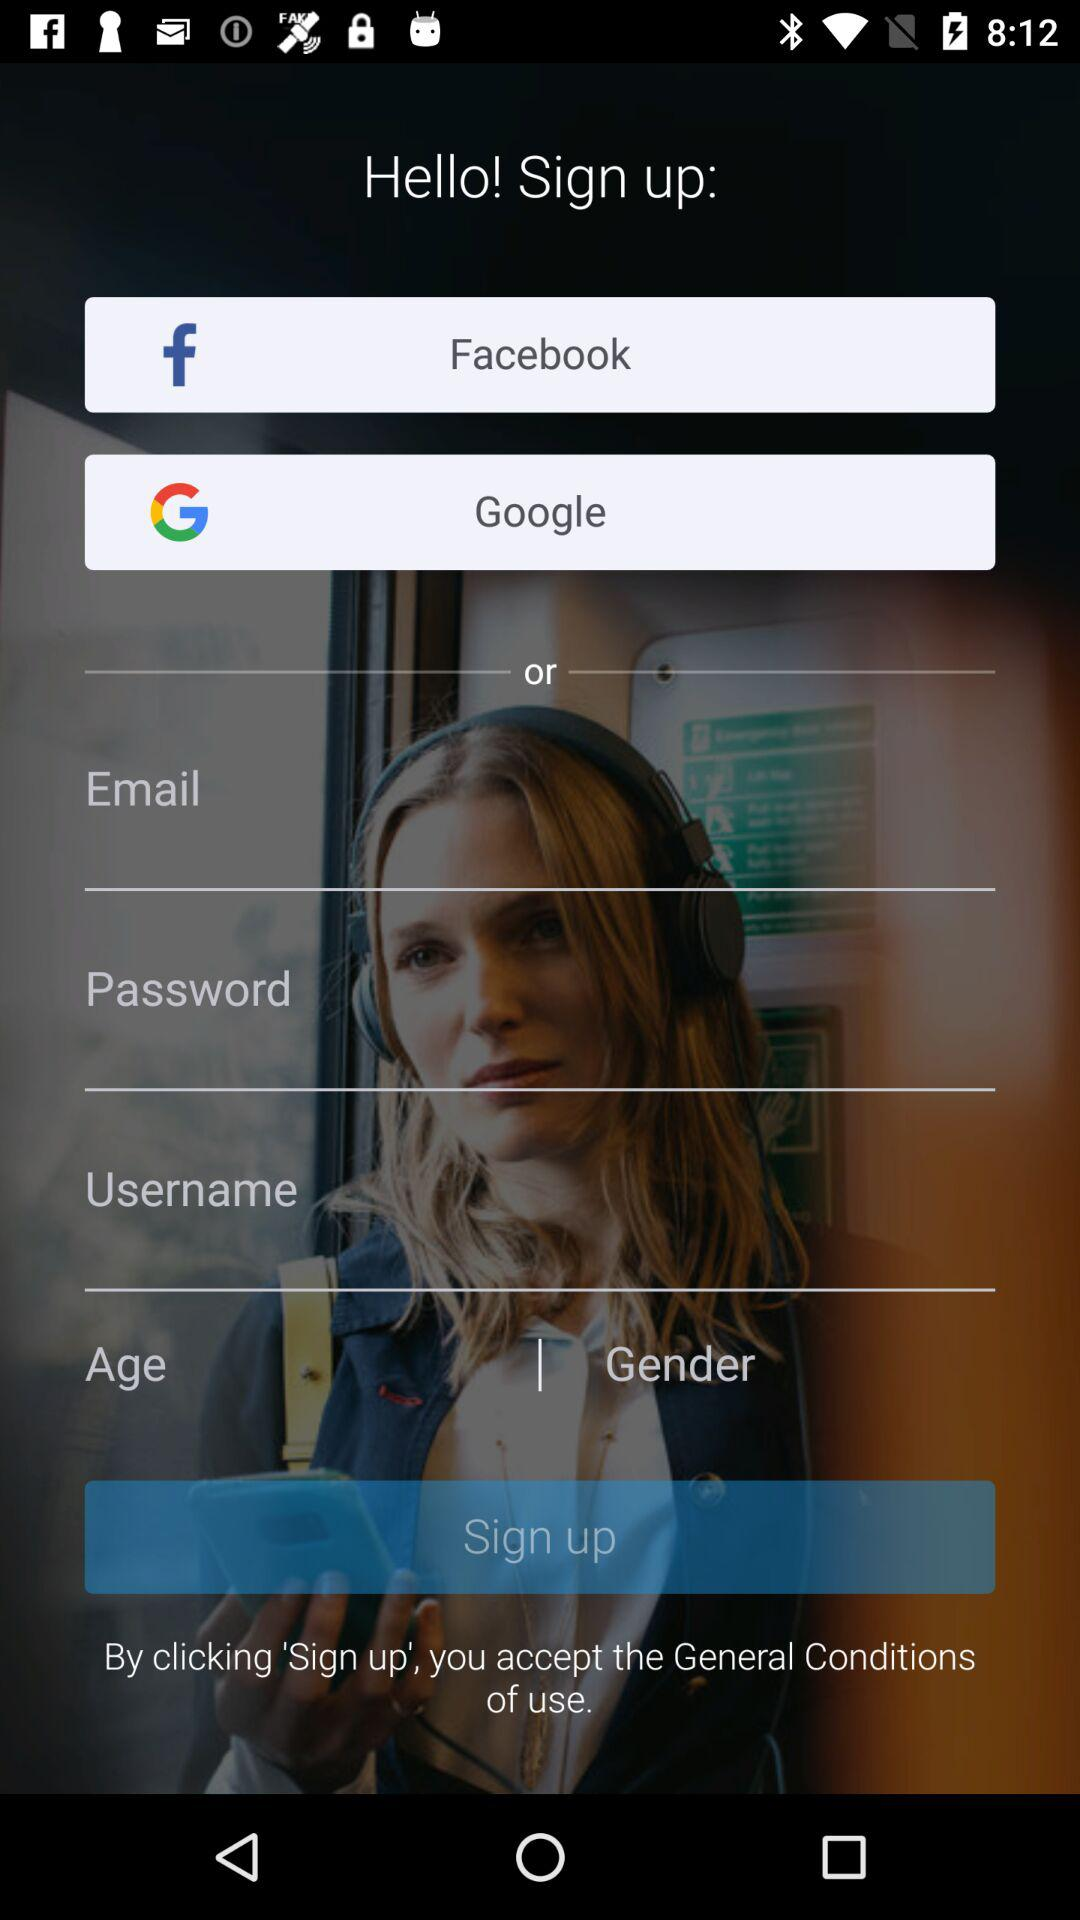Which application could I use to sign up? You could use "Facebook" or "Google" to sign up. 